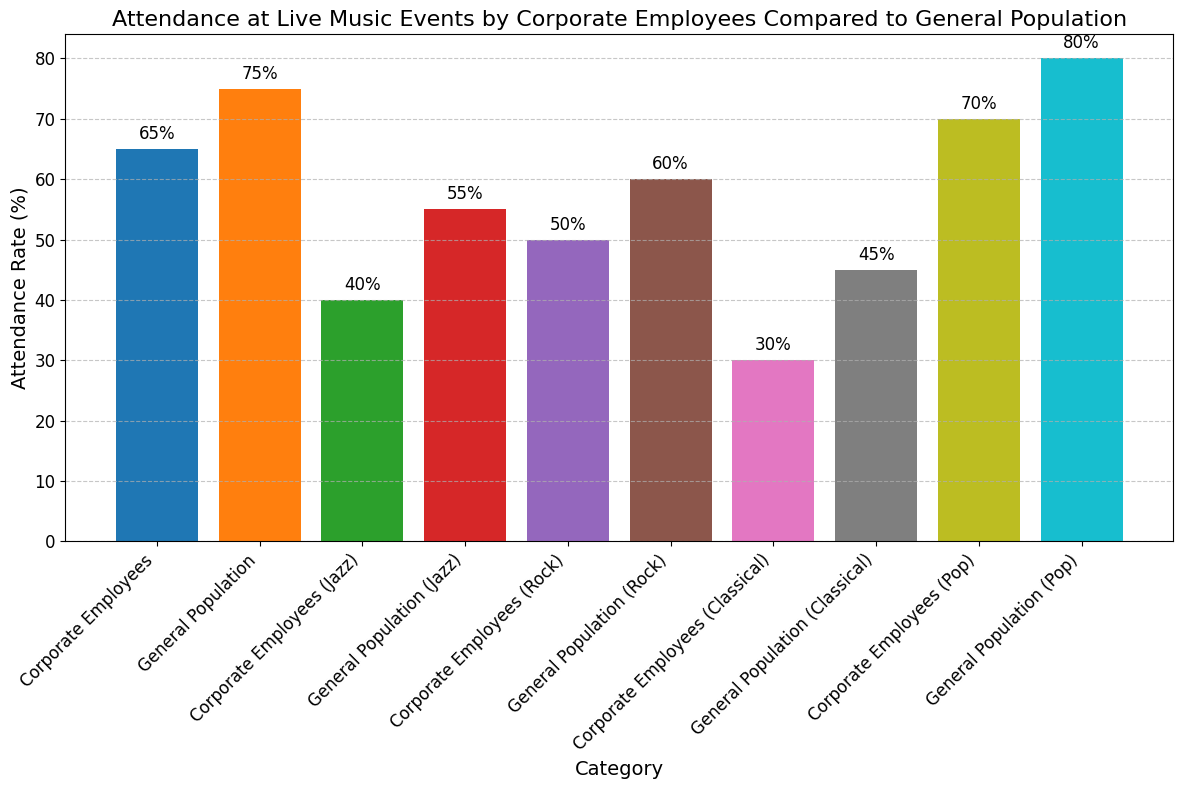What's the attendance rate for corporate employees at jazz events? Look for the bar labeled "Corporate Employees (Jazz)" and read the attendance rate value on top of the bar.
Answer: 40% Which group has a higher attendance rate at pop events, corporate employees or the general population? Compare the heights of the bars labeled "Corporate Employees (Pop)" and "General Population (Pop)" and see which one is higher.
Answer: General Population What's the difference in attendance rates between corporate employees and the general population at classical events? Subtract the attendance rate of corporate employees at classical events (30%) from the attendance rate of the general population at the same events (45%) to get the difference.
Answer: 15% Which category of music has the highest attendance rate for corporate employees? Look for the highest bar among all categories labeled with "Corporate Employees" and determine the category.
Answer: Pop What is the average attendance rate for corporate employees across all listed music genres? Sum the attendance rates for corporate employees in each category (65% + 40% + 50% + 30% + 70%) and divide by the number of categories (5). (65 + 40 + 50 + 30 + 70) / 5 = 255 / 5 = 51.
Answer: 51% Which group attends live music events more in general (all categories combined), corporate employees or the general population? Find the combined total for each group by summing the attendance rates: Corporate Employees (65 + 40 + 50 + 30 + 70 = 255) and General Population (75 + 55 + 60 + 45 + 80 = 315). Compare the totals.
Answer: General Population How many categories have a higher attendance rate for the general population compared to corporate employees? Count the number of categories where the attendance rate for the general population is higher by looking at each pair and comparing the values. 
All categories show a higher attendance rate for the general population compared to corporate employees.
Answer: 5 (All categories) What's the percentage increase in attendance rate from corporate employees to the general population for classical events? Calculate the percentage increase using the formula: (New Value - Old Value) / Old Value * 100. 
(45 - 30) / 30 * 100 = 15 / 30 * 100 = 50%.
Answer: 50% How many categories have an attendance rate above 60% for corporate employees? Identify all the categories for corporate employees with bars greater than 60%:
- Corporate Employees Overall: 65%
- Corporate Employees (Pop): 70%
Only two categories meet this condition.
Answer: 2 